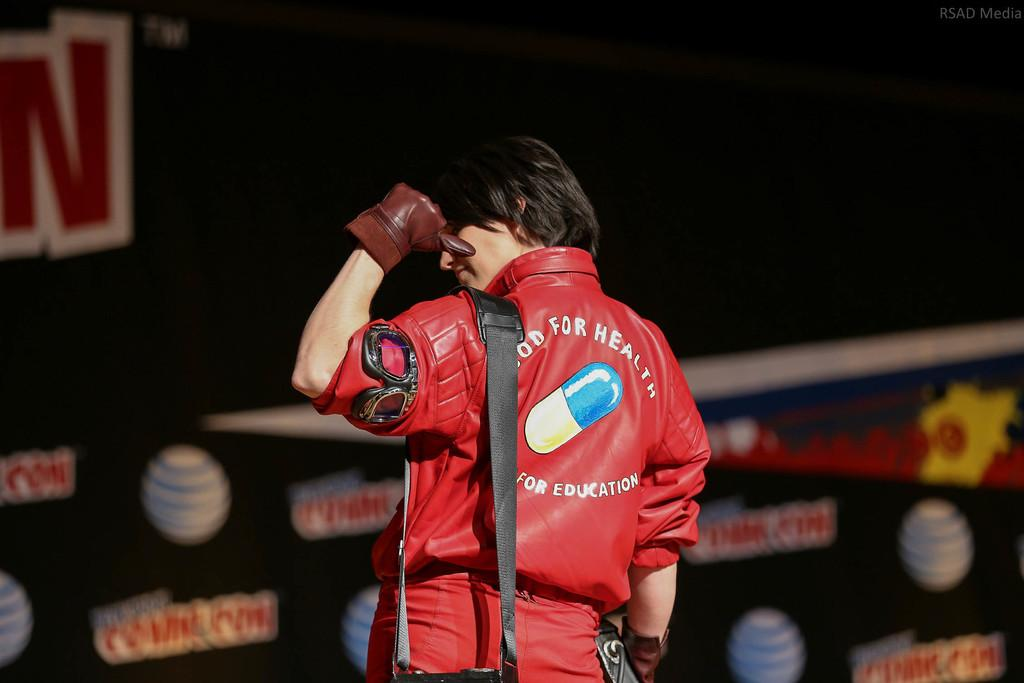What is the person in the image wearing on their hands? The person in the image is wearing gloves. What can be seen in the background of the image? The background of the image is black with images. What type of humor is the person in the image displaying with their muscles? There is no indication of humor or muscles in the image; the person is simply wearing gloves. 